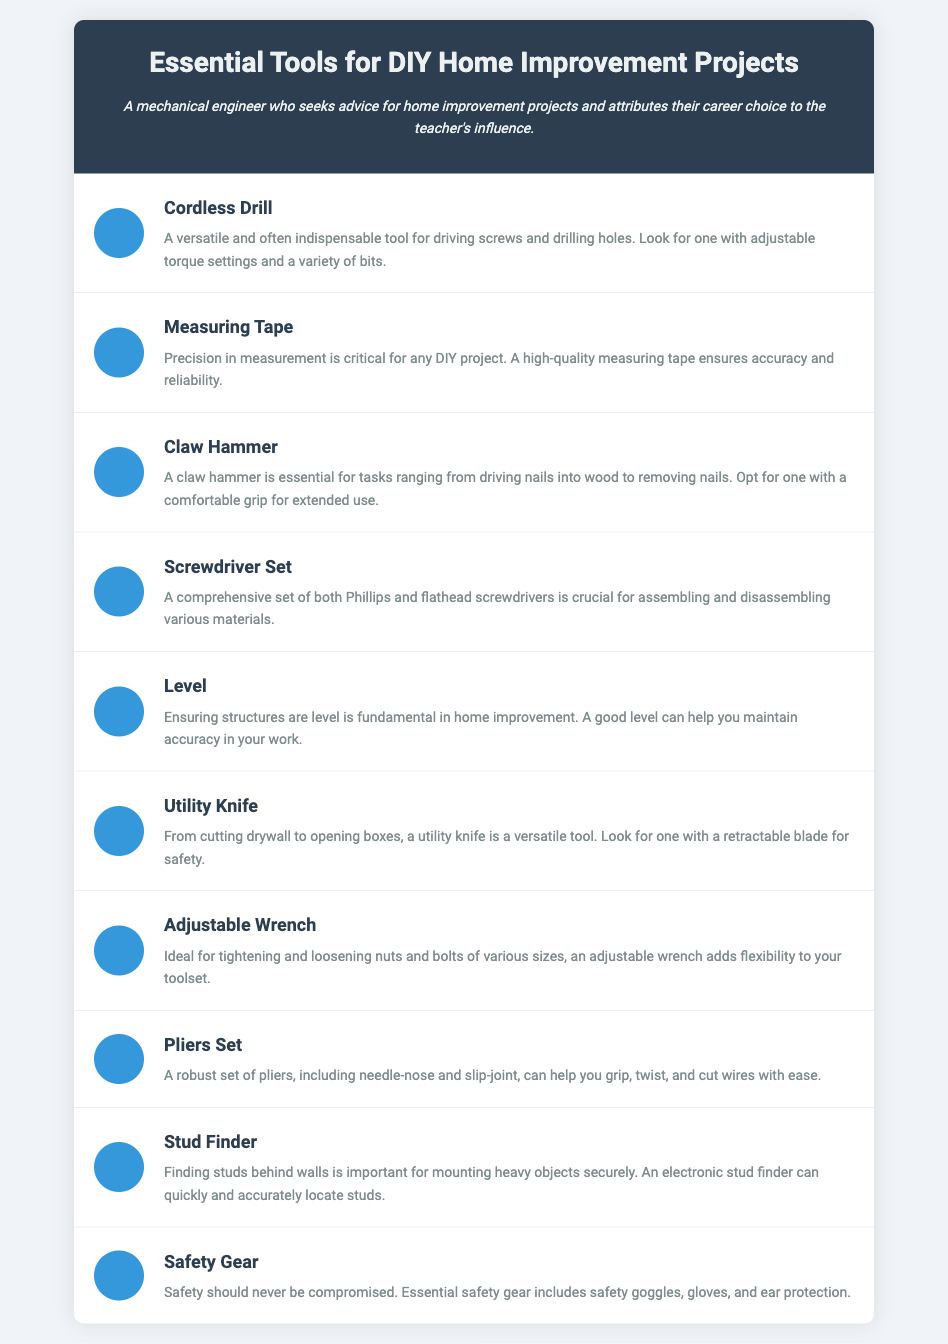What is the first tool listed? The first tool listed in the document is the Cordless Drill.
Answer: Cordless Drill How many tools are included in this infographic? The infographic includes a total of 10 essential tools.
Answer: 10 Which tool is described as versatile for cutting drywall? The tool described as versatile for cutting drywall is the Utility Knife.
Answer: Utility Knife What component is critical for ensuring precision in measurement? The component critical for ensuring precision in measurement is the Measuring Tape.
Answer: Measuring Tape What type of safety gear is mentioned? The safety gear mentioned includes safety goggles, gloves, and ear protection.
Answer: Safety goggles, gloves, and ear protection What tool is specifically used to locate studs behind walls? The tool specifically used to locate studs behind walls is the Stud Finder.
Answer: Stud Finder Which tool is essential for tightening and loosening nuts and bolts? The tool essential for tightening and loosening nuts and bolts is the Adjustable Wrench.
Answer: Adjustable Wrench What is the function of the Claw Hammer? The Claw Hammer is used for driving nails into wood and removing nails.
Answer: Driving nails and removing nails What is mentioned as important for mounting heavy objects? The document mentions finding studs behind walls as important for mounting heavy objects.
Answer: Finding studs Which tool helps maintain accuracy in DIY projects? The tool that helps maintain accuracy in DIY projects is the Level.
Answer: Level 